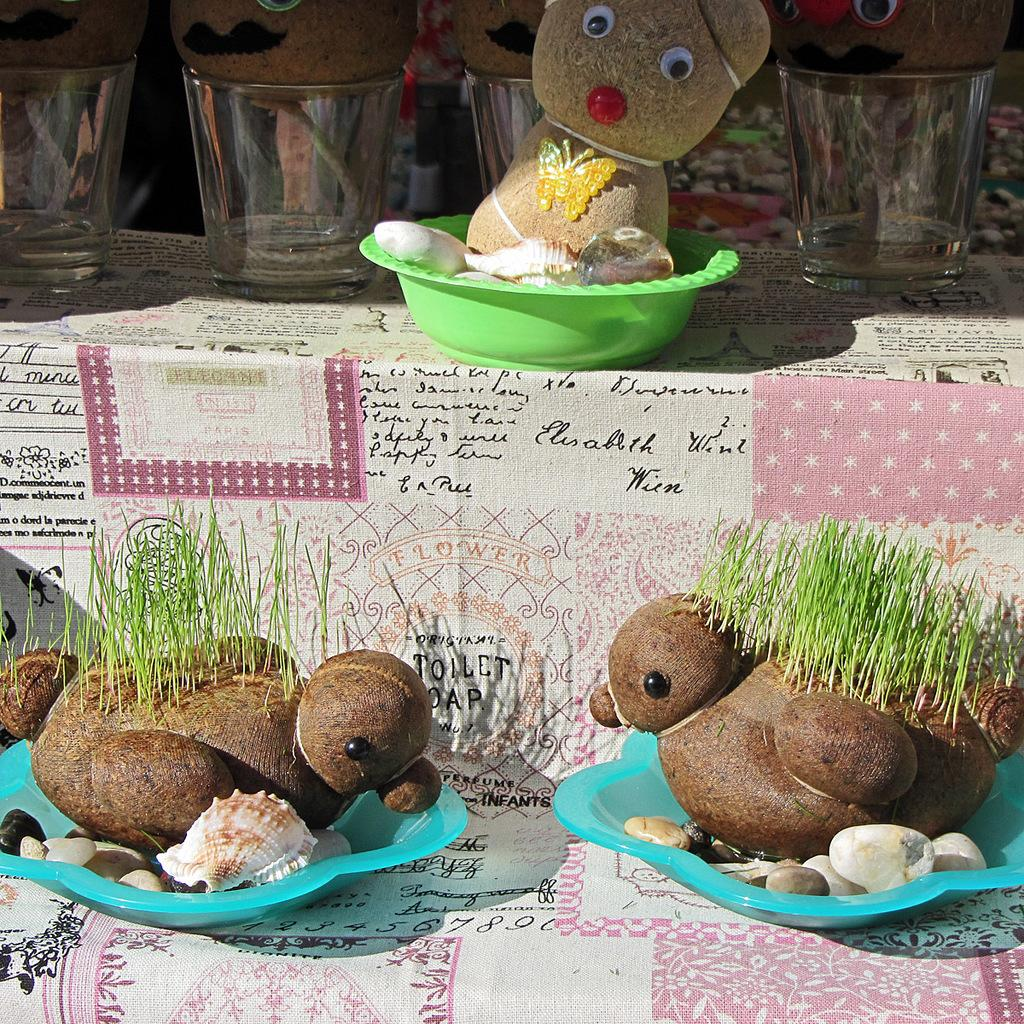What objects are in the foreground of the picture? There are plates in the foreground of the picture. What is on the plates in the foreground? The plates contain stones and duck-shaped toys. What can be seen at the top of the image? There are glasses, plates, tables, and teddy bears at the top of the image. How does the rain affect the noise level in the image? There is no rain present in the image, so it cannot affect the noise level. 